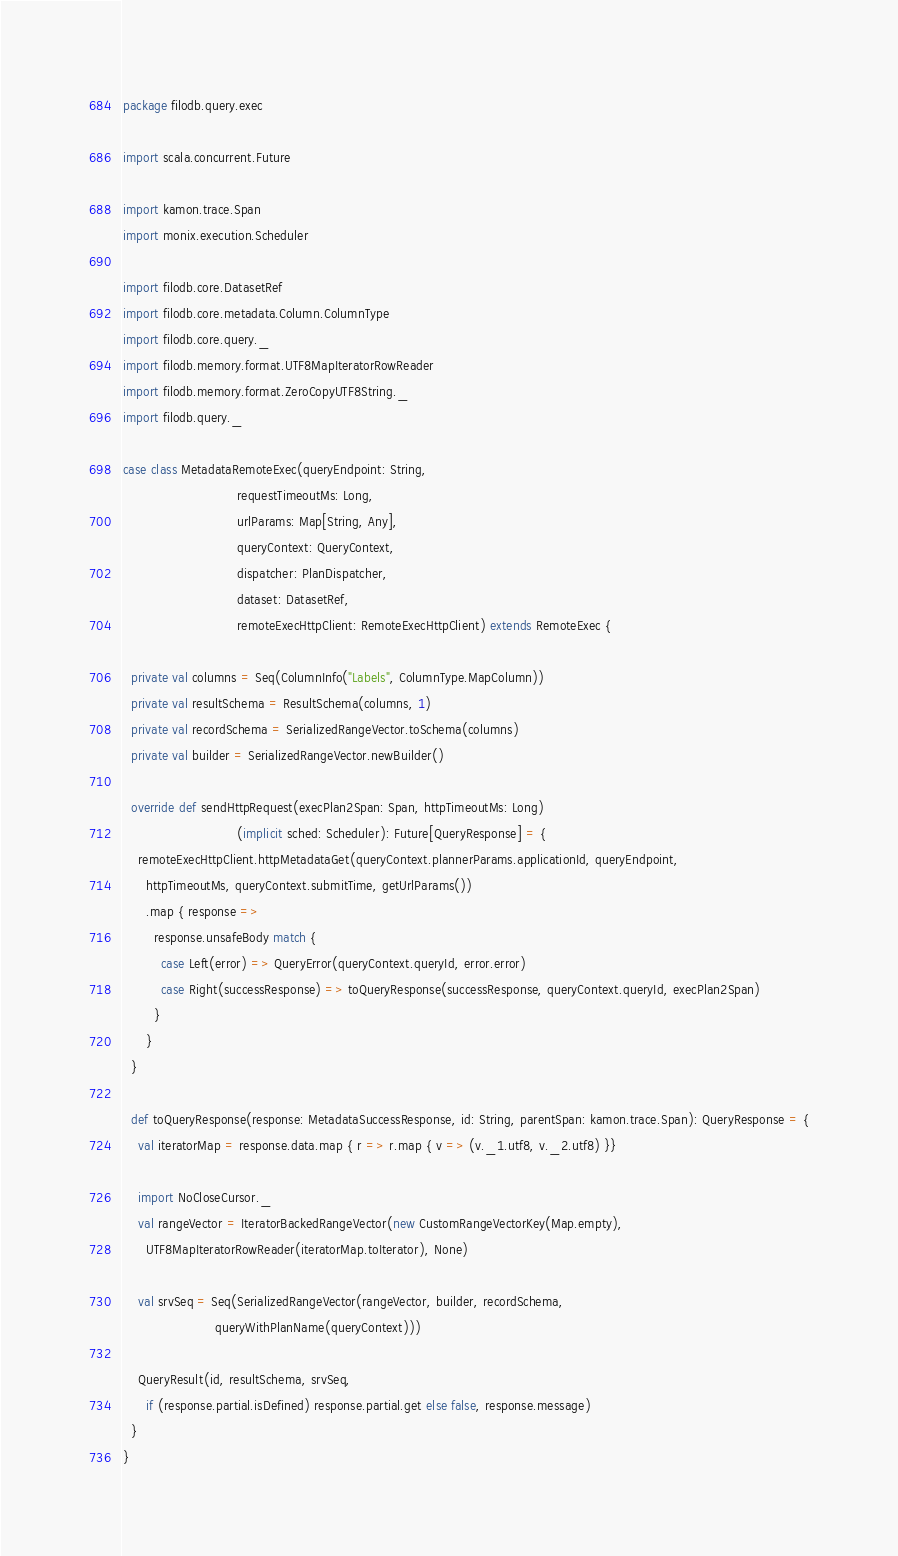<code> <loc_0><loc_0><loc_500><loc_500><_Scala_>package filodb.query.exec

import scala.concurrent.Future

import kamon.trace.Span
import monix.execution.Scheduler

import filodb.core.DatasetRef
import filodb.core.metadata.Column.ColumnType
import filodb.core.query._
import filodb.memory.format.UTF8MapIteratorRowReader
import filodb.memory.format.ZeroCopyUTF8String._
import filodb.query._

case class MetadataRemoteExec(queryEndpoint: String,
                              requestTimeoutMs: Long,
                              urlParams: Map[String, Any],
                              queryContext: QueryContext,
                              dispatcher: PlanDispatcher,
                              dataset: DatasetRef,
                              remoteExecHttpClient: RemoteExecHttpClient) extends RemoteExec {

  private val columns = Seq(ColumnInfo("Labels", ColumnType.MapColumn))
  private val resultSchema = ResultSchema(columns, 1)
  private val recordSchema = SerializedRangeVector.toSchema(columns)
  private val builder = SerializedRangeVector.newBuilder()

  override def sendHttpRequest(execPlan2Span: Span, httpTimeoutMs: Long)
                              (implicit sched: Scheduler): Future[QueryResponse] = {
    remoteExecHttpClient.httpMetadataGet(queryContext.plannerParams.applicationId, queryEndpoint,
      httpTimeoutMs, queryContext.submitTime, getUrlParams())
      .map { response =>
        response.unsafeBody match {
          case Left(error) => QueryError(queryContext.queryId, error.error)
          case Right(successResponse) => toQueryResponse(successResponse, queryContext.queryId, execPlan2Span)
        }
      }
  }

  def toQueryResponse(response: MetadataSuccessResponse, id: String, parentSpan: kamon.trace.Span): QueryResponse = {
    val iteratorMap = response.data.map { r => r.map { v => (v._1.utf8, v._2.utf8) }}

    import NoCloseCursor._
    val rangeVector = IteratorBackedRangeVector(new CustomRangeVectorKey(Map.empty),
      UTF8MapIteratorRowReader(iteratorMap.toIterator), None)

    val srvSeq = Seq(SerializedRangeVector(rangeVector, builder, recordSchema,
                        queryWithPlanName(queryContext)))

    QueryResult(id, resultSchema, srvSeq,
      if (response.partial.isDefined) response.partial.get else false, response.message)
  }
}
</code> 